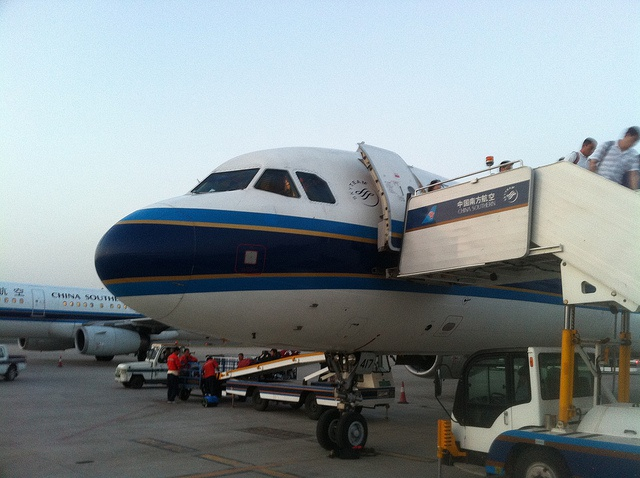Describe the objects in this image and their specific colors. I can see airplane in lightblue, black, gray, and darkgray tones, truck in lightblue, black, darkgray, gray, and blue tones, airplane in lightblue, black, gray, and darkgray tones, people in lightblue, darkgray, and gray tones, and truck in lightblue, black, gray, darkgray, and purple tones in this image. 